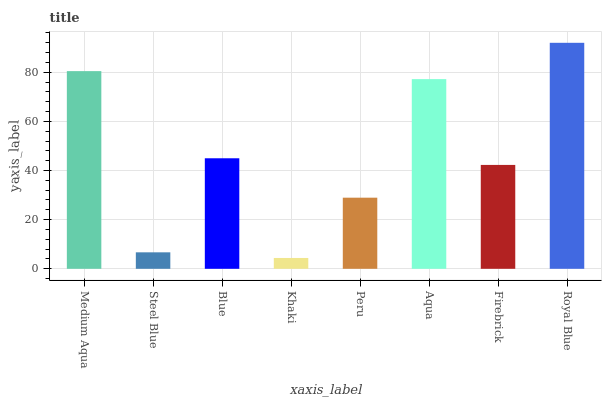Is Steel Blue the minimum?
Answer yes or no. No. Is Steel Blue the maximum?
Answer yes or no. No. Is Medium Aqua greater than Steel Blue?
Answer yes or no. Yes. Is Steel Blue less than Medium Aqua?
Answer yes or no. Yes. Is Steel Blue greater than Medium Aqua?
Answer yes or no. No. Is Medium Aqua less than Steel Blue?
Answer yes or no. No. Is Blue the high median?
Answer yes or no. Yes. Is Firebrick the low median?
Answer yes or no. Yes. Is Royal Blue the high median?
Answer yes or no. No. Is Medium Aqua the low median?
Answer yes or no. No. 